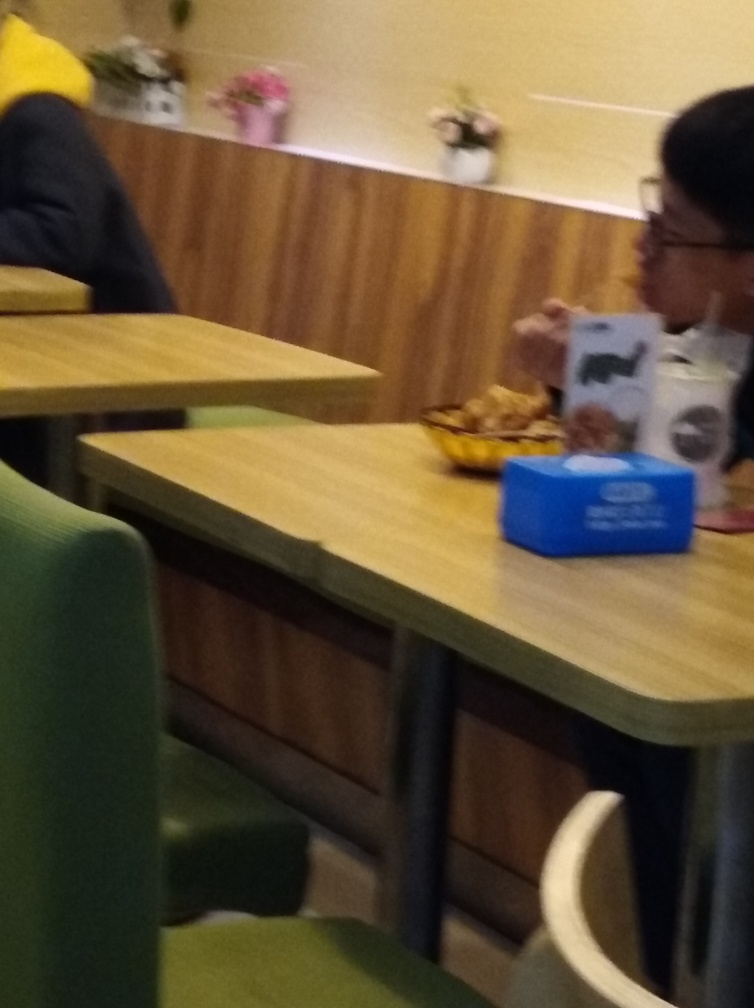Is the image blurry?
A. Yes
B. Occasionally
C. Partially
Answer with the option's letter from the given choices directly. The image is indeed blurry; it lacks sharpness and detail throughout, which affects the entire photograph and not just a portion of it. So the correct response would be 'A. Yes', as the blurriness is a consistent attribute of the image. 